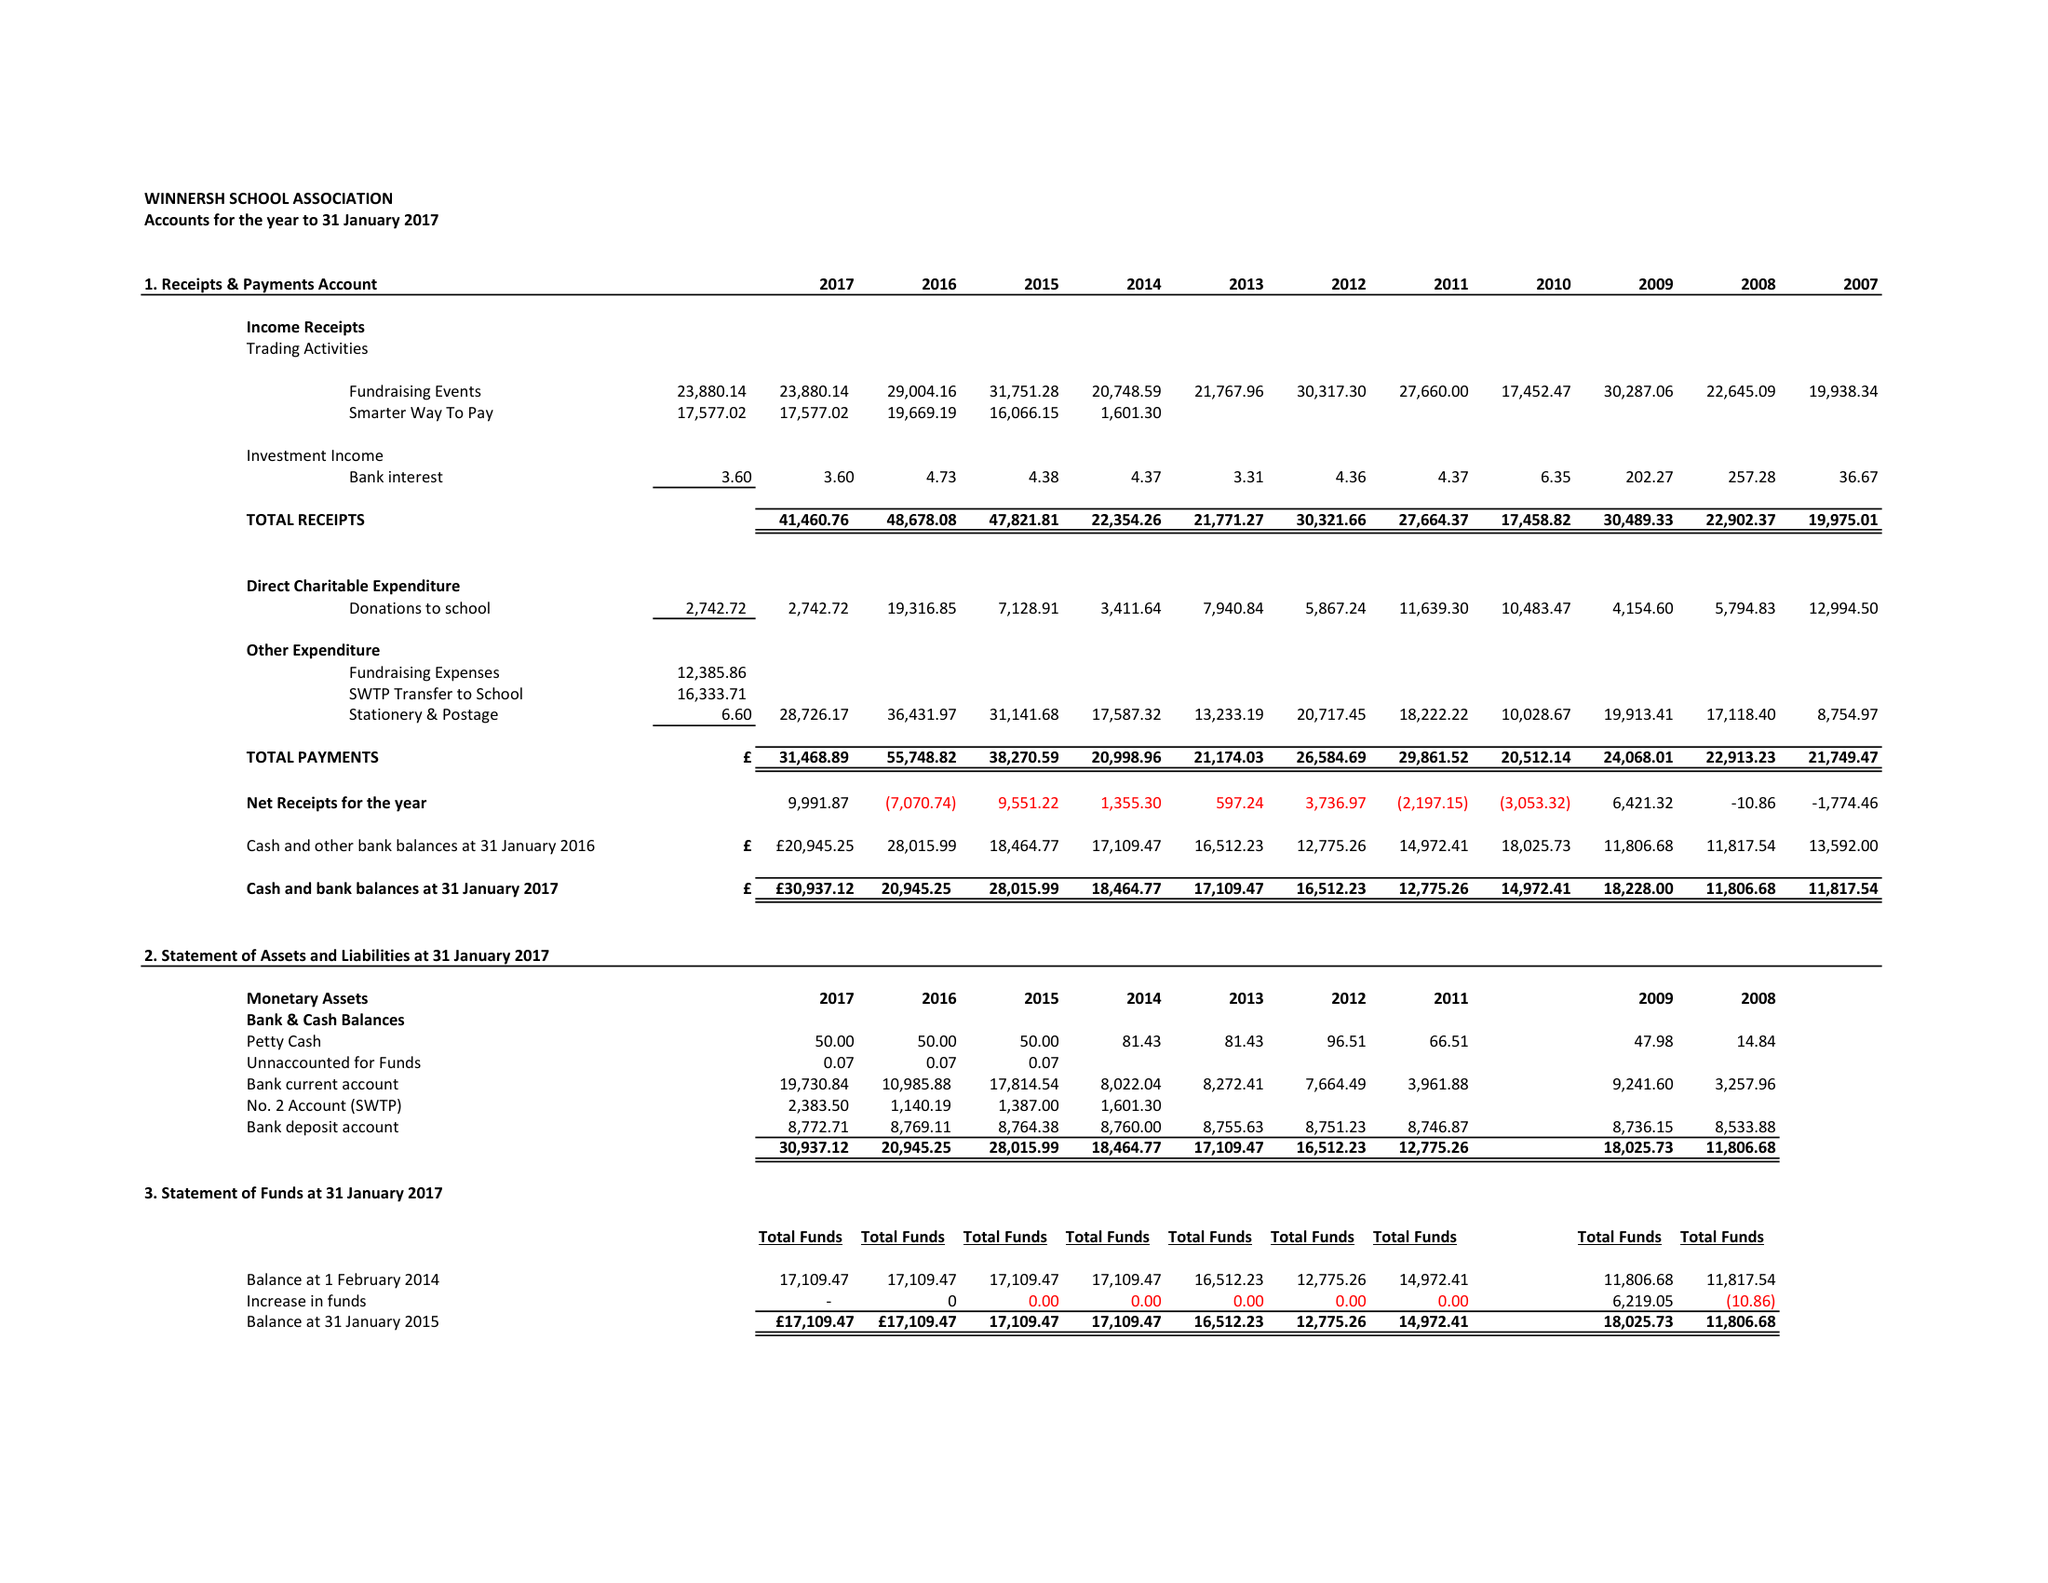What is the value for the income_annually_in_british_pounds?
Answer the question using a single word or phrase. 41461.00 